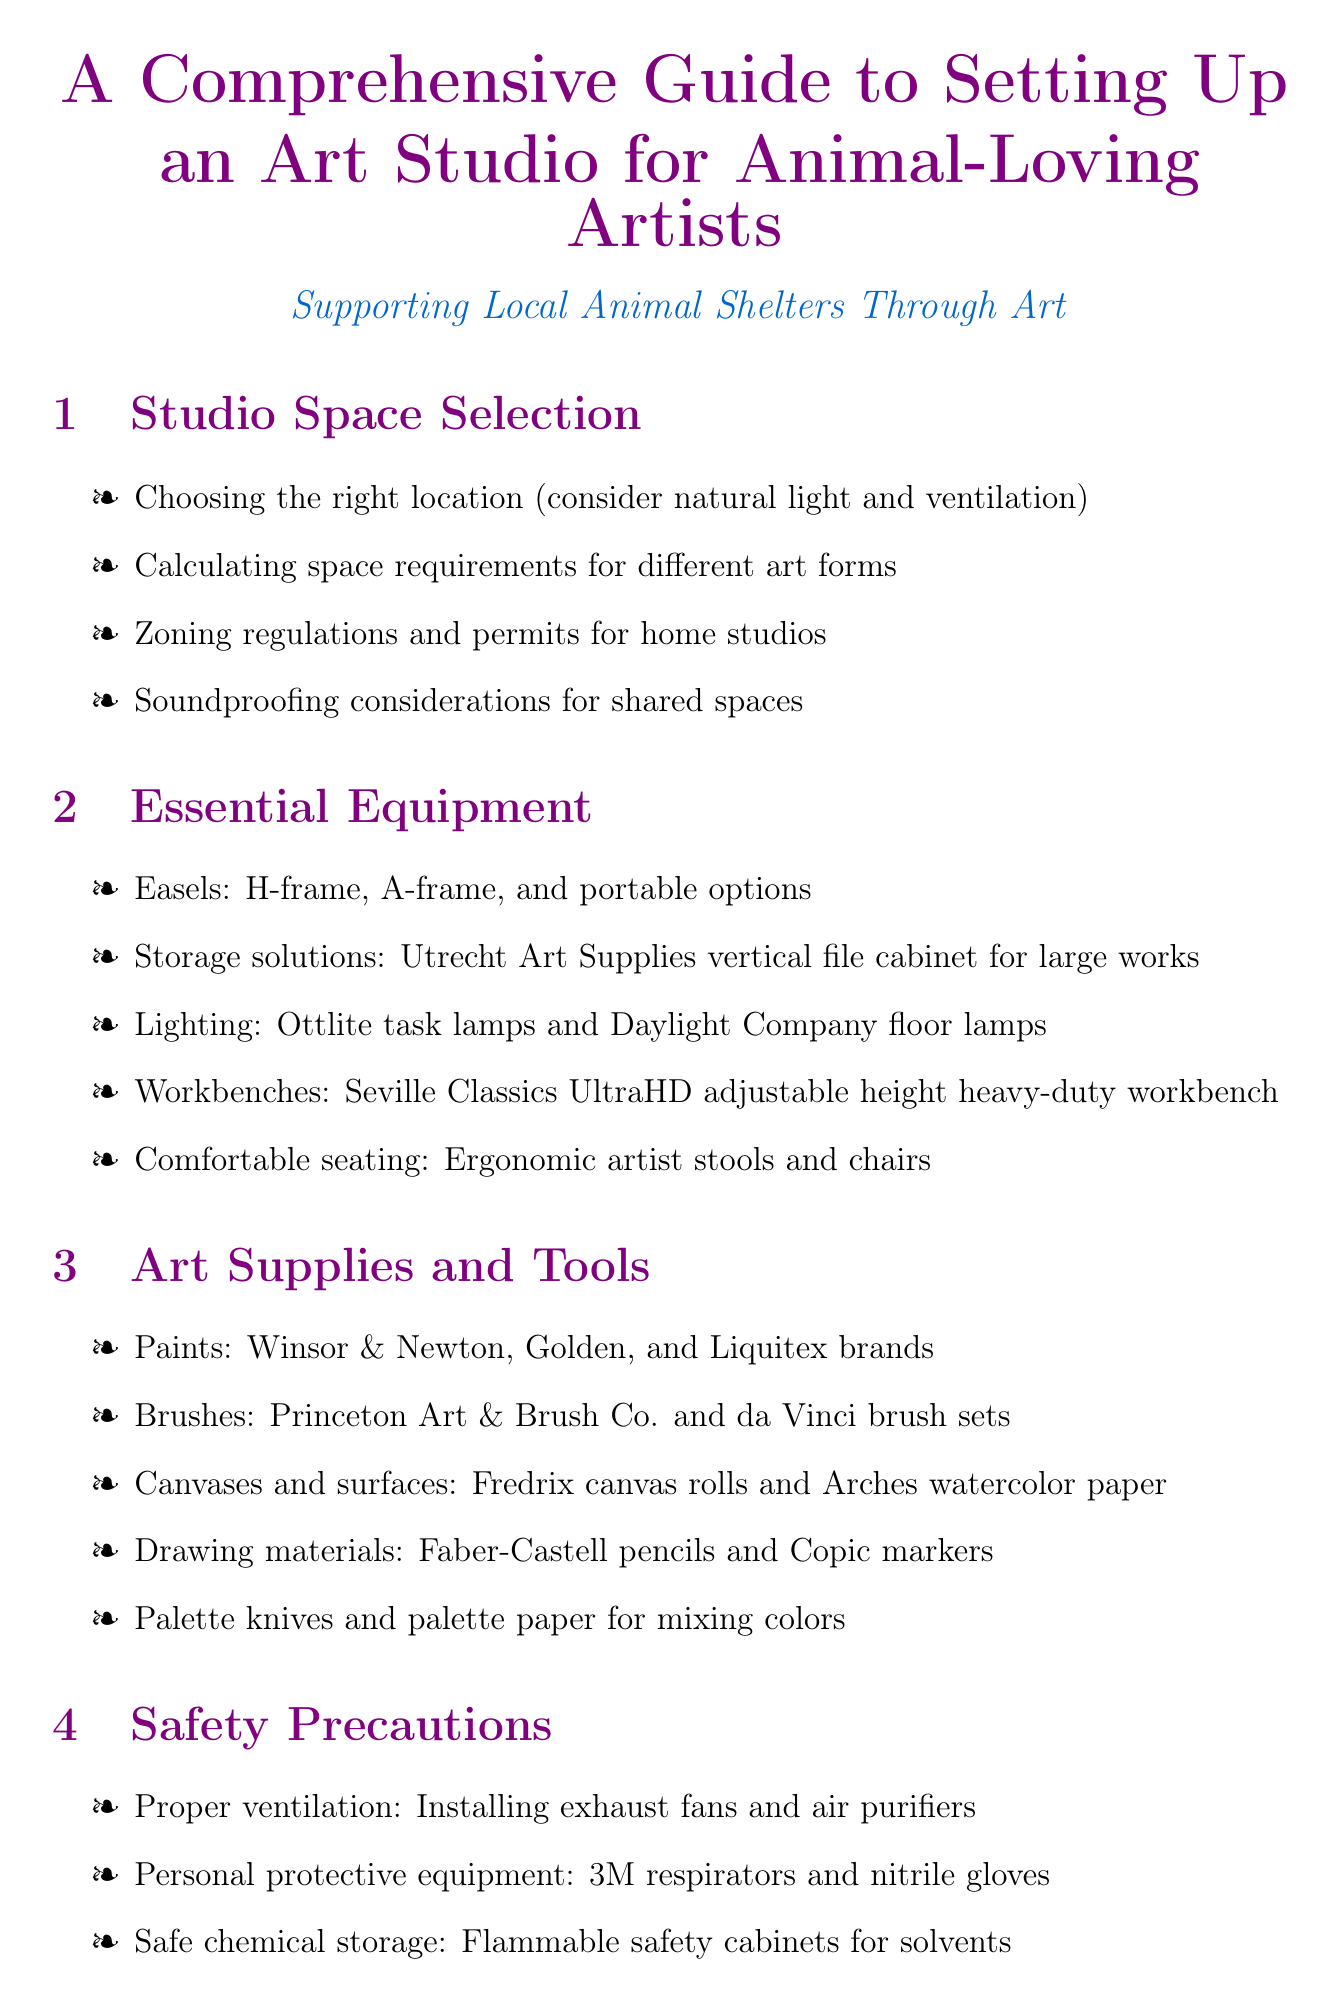what should be considered when choosing a studio location? The document mentions natural light and ventilation as key factors in choosing a studio location.
Answer: natural light and ventilation name two brands of paints recommended in the document. The document lists Winsor & Newton and Liquitex as recommended paint brands.
Answer: Winsor & Newton, Liquitex what type of stools are suggested for comfortable seating? The document recommends ergonomic artist stools for comfortable seating.
Answer: ergonomic artist stools which equipment is listed for safe chemical storage? The document specifies flammable safety cabinets for solvents as a safe chemical storage solution.
Answer: flammable safety cabinets how many sections are in the guide? The document contains nine distinct sections covering various aspects of setting up an art studio.
Answer: nine what should be included in the photography area setup? The document mentions creating a photography area for documenting artwork as part of the organization and workflow.
Answer: documenting artwork who should be welcomed in the client and charity considerations section? The document suggests creating a welcoming area for potential buyers and shelter representatives.
Answer: potential buyers and shelter representatives list one recommended type of workbench. The document recommends the Seville Classics UltraHD adjustable height heavy-duty workbench.
Answer: Seville Classics UltraHD adjustable height heavy-duty workbench what is a key safety precaution mentioned in the document? The document highlights proper ventilation as a critical safety precaution for artists.
Answer: proper ventilation 